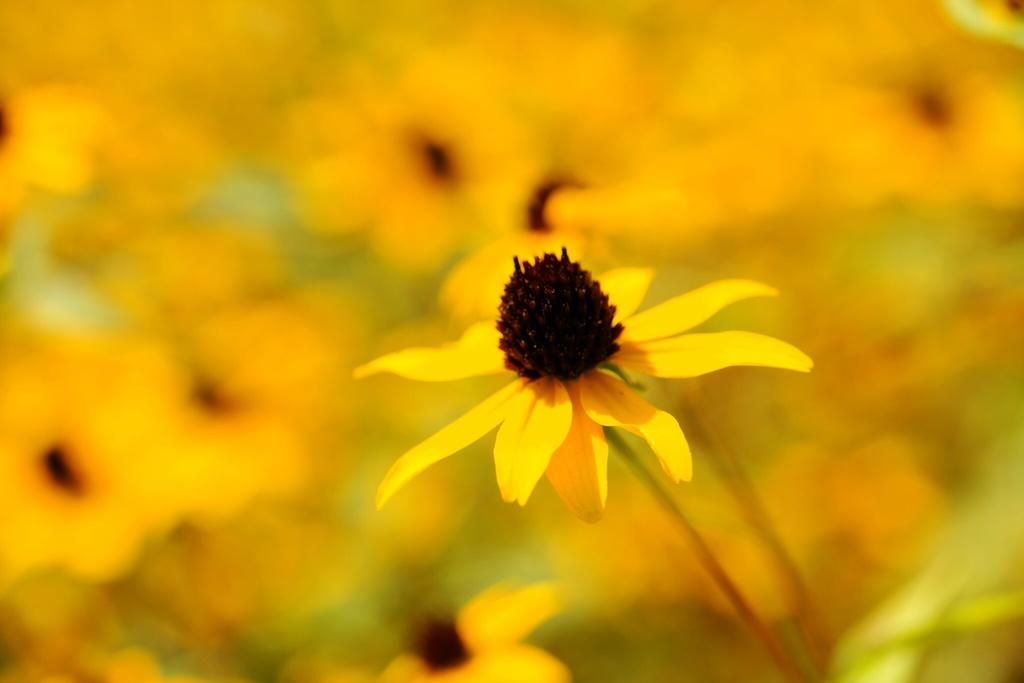What is the main subject in the foreground of the image? There is a flower in the foreground of the image. What can be seen in the background of the image? There is a group of flowers in the background of the image. How would you describe the background of the image? The background is blurry. Can you see the coast in the background of the image? There is no coast visible in the image; it features flowers in the foreground and background. 